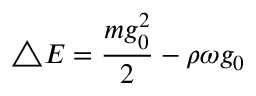<formula> <loc_0><loc_0><loc_500><loc_500>\bigtriangleup E = \frac { m g _ { 0 } ^ { 2 } } { 2 } - \rho \omega g _ { 0 }</formula> 